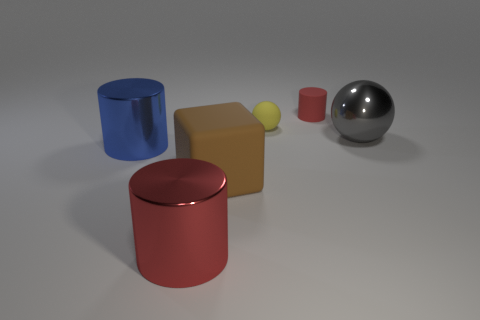Subtract all red balls. Subtract all gray blocks. How many balls are left? 2 Add 2 shiny balls. How many objects exist? 8 Subtract all balls. How many objects are left? 4 Subtract 0 gray blocks. How many objects are left? 6 Subtract all large matte blocks. Subtract all small rubber cylinders. How many objects are left? 4 Add 6 metallic cylinders. How many metallic cylinders are left? 8 Add 4 blue metal things. How many blue metal things exist? 5 